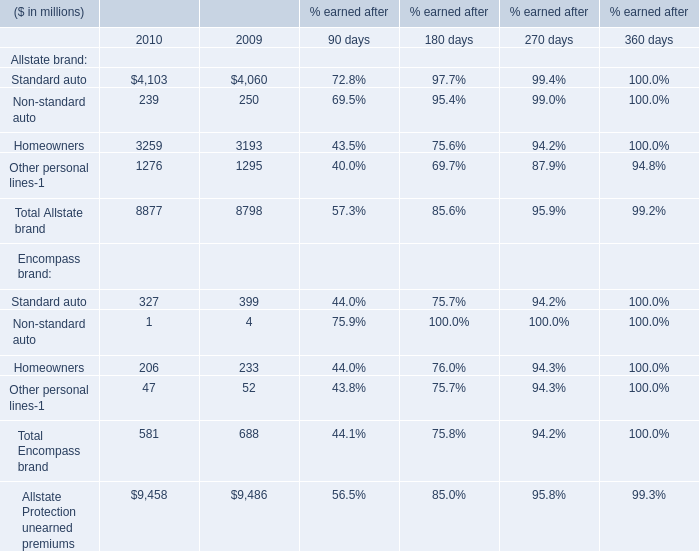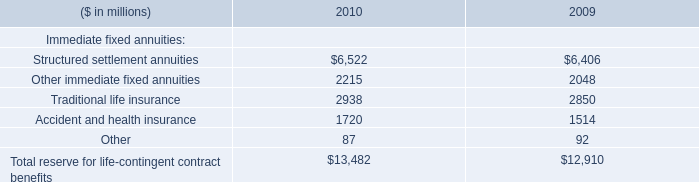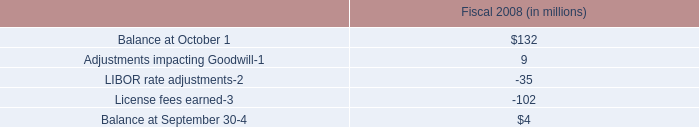What's the average of Allstate brand in 2010? (in millions) 
Computations: ((((4103 + 239) + 3259) + 1276) / 4)
Answer: 2219.25. 